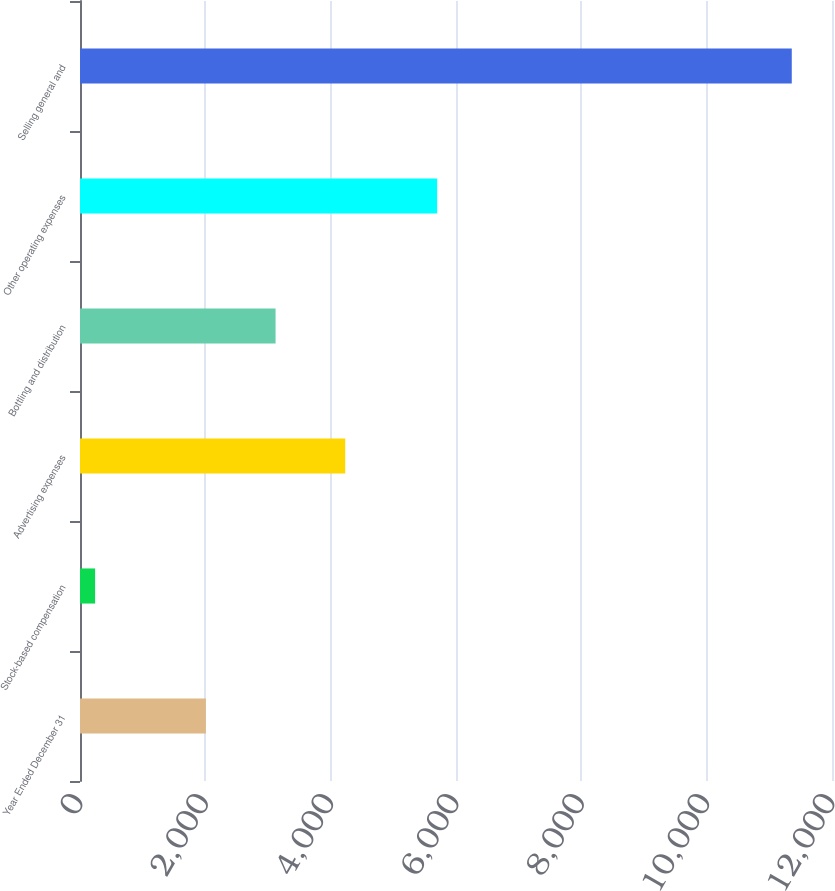Convert chart to OTSL. <chart><loc_0><loc_0><loc_500><loc_500><bar_chart><fcel>Year Ended December 31<fcel>Stock-based compensation<fcel>Advertising expenses<fcel>Bottling and distribution<fcel>Other operating expenses<fcel>Selling general and<nl><fcel>2009<fcel>241<fcel>4232.4<fcel>3120.7<fcel>5699<fcel>11358<nl></chart> 